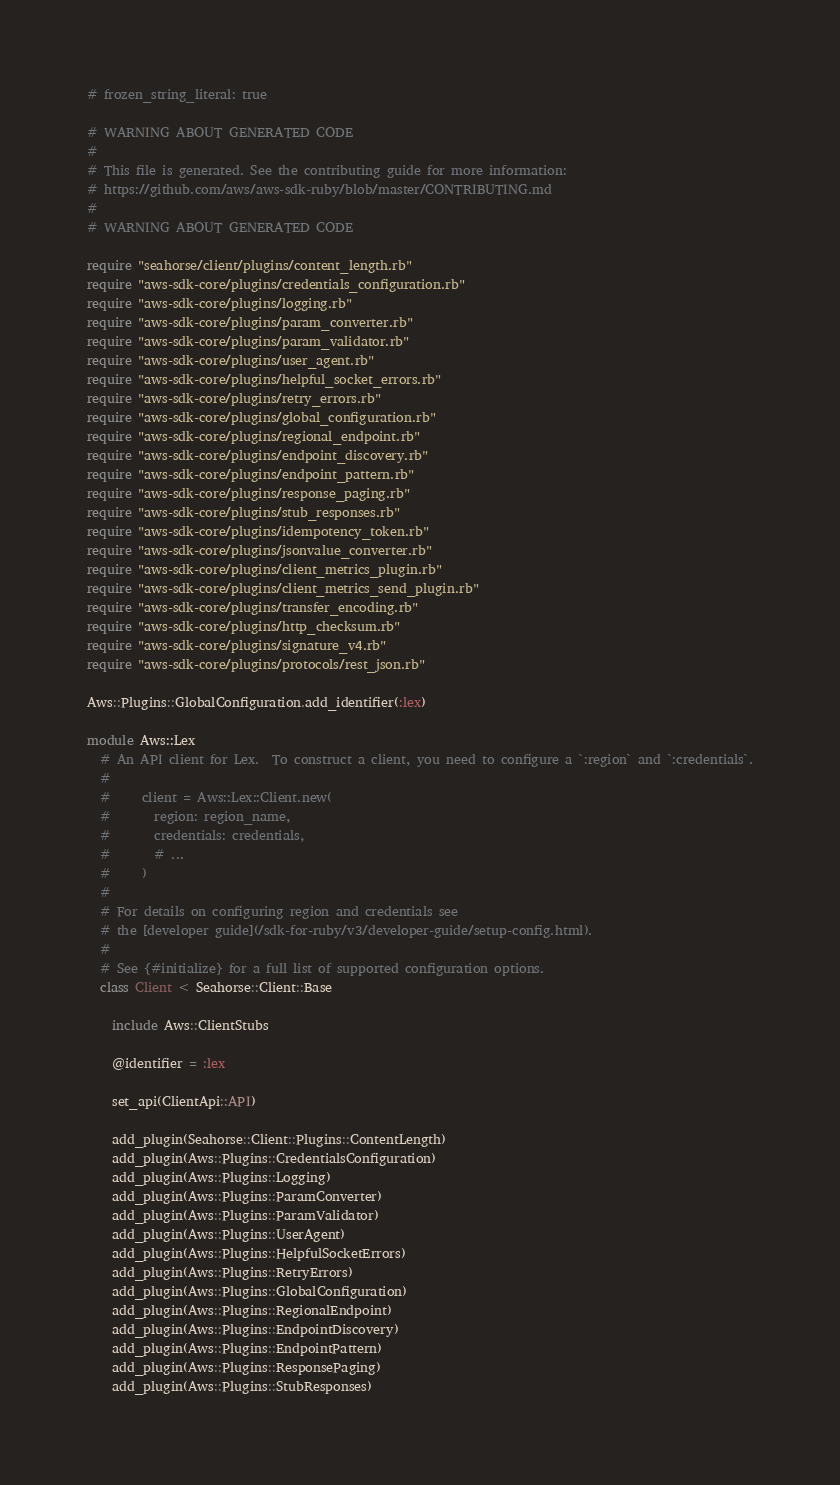Convert code to text. <code><loc_0><loc_0><loc_500><loc_500><_Crystal_># frozen_string_literal: true

# WARNING ABOUT GENERATED CODE
#
# This file is generated. See the contributing guide for more information:
# https://github.com/aws/aws-sdk-ruby/blob/master/CONTRIBUTING.md
#
# WARNING ABOUT GENERATED CODE

require "seahorse/client/plugins/content_length.rb"
require "aws-sdk-core/plugins/credentials_configuration.rb"
require "aws-sdk-core/plugins/logging.rb"
require "aws-sdk-core/plugins/param_converter.rb"
require "aws-sdk-core/plugins/param_validator.rb"
require "aws-sdk-core/plugins/user_agent.rb"
require "aws-sdk-core/plugins/helpful_socket_errors.rb"
require "aws-sdk-core/plugins/retry_errors.rb"
require "aws-sdk-core/plugins/global_configuration.rb"
require "aws-sdk-core/plugins/regional_endpoint.rb"
require "aws-sdk-core/plugins/endpoint_discovery.rb"
require "aws-sdk-core/plugins/endpoint_pattern.rb"
require "aws-sdk-core/plugins/response_paging.rb"
require "aws-sdk-core/plugins/stub_responses.rb"
require "aws-sdk-core/plugins/idempotency_token.rb"
require "aws-sdk-core/plugins/jsonvalue_converter.rb"
require "aws-sdk-core/plugins/client_metrics_plugin.rb"
require "aws-sdk-core/plugins/client_metrics_send_plugin.rb"
require "aws-sdk-core/plugins/transfer_encoding.rb"
require "aws-sdk-core/plugins/http_checksum.rb"
require "aws-sdk-core/plugins/signature_v4.rb"
require "aws-sdk-core/plugins/protocols/rest_json.rb"

Aws::Plugins::GlobalConfiguration.add_identifier(:lex)

module Aws::Lex
  # An API client for Lex.  To construct a client, you need to configure a `:region` and `:credentials`.
  #
  #     client = Aws::Lex::Client.new(
  #       region: region_name,
  #       credentials: credentials,
  #       # ...
  #     )
  #
  # For details on configuring region and credentials see
  # the [developer guide](/sdk-for-ruby/v3/developer-guide/setup-config.html).
  #
  # See {#initialize} for a full list of supported configuration options.
  class Client < Seahorse::Client::Base

    include Aws::ClientStubs

    @identifier = :lex

    set_api(ClientApi::API)

    add_plugin(Seahorse::Client::Plugins::ContentLength)
    add_plugin(Aws::Plugins::CredentialsConfiguration)
    add_plugin(Aws::Plugins::Logging)
    add_plugin(Aws::Plugins::ParamConverter)
    add_plugin(Aws::Plugins::ParamValidator)
    add_plugin(Aws::Plugins::UserAgent)
    add_plugin(Aws::Plugins::HelpfulSocketErrors)
    add_plugin(Aws::Plugins::RetryErrors)
    add_plugin(Aws::Plugins::GlobalConfiguration)
    add_plugin(Aws::Plugins::RegionalEndpoint)
    add_plugin(Aws::Plugins::EndpointDiscovery)
    add_plugin(Aws::Plugins::EndpointPattern)
    add_plugin(Aws::Plugins::ResponsePaging)
    add_plugin(Aws::Plugins::StubResponses)</code> 